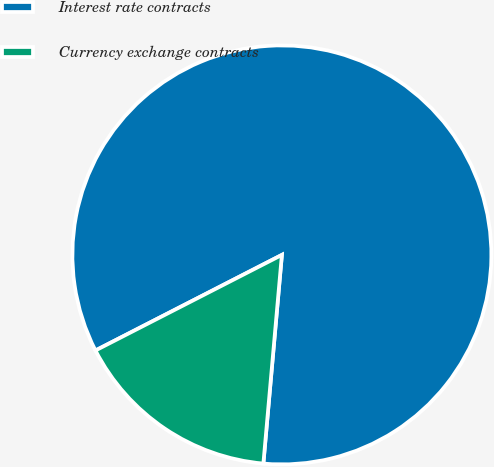Convert chart. <chart><loc_0><loc_0><loc_500><loc_500><pie_chart><fcel>Interest rate contracts<fcel>Currency exchange contracts<nl><fcel>83.95%<fcel>16.05%<nl></chart> 